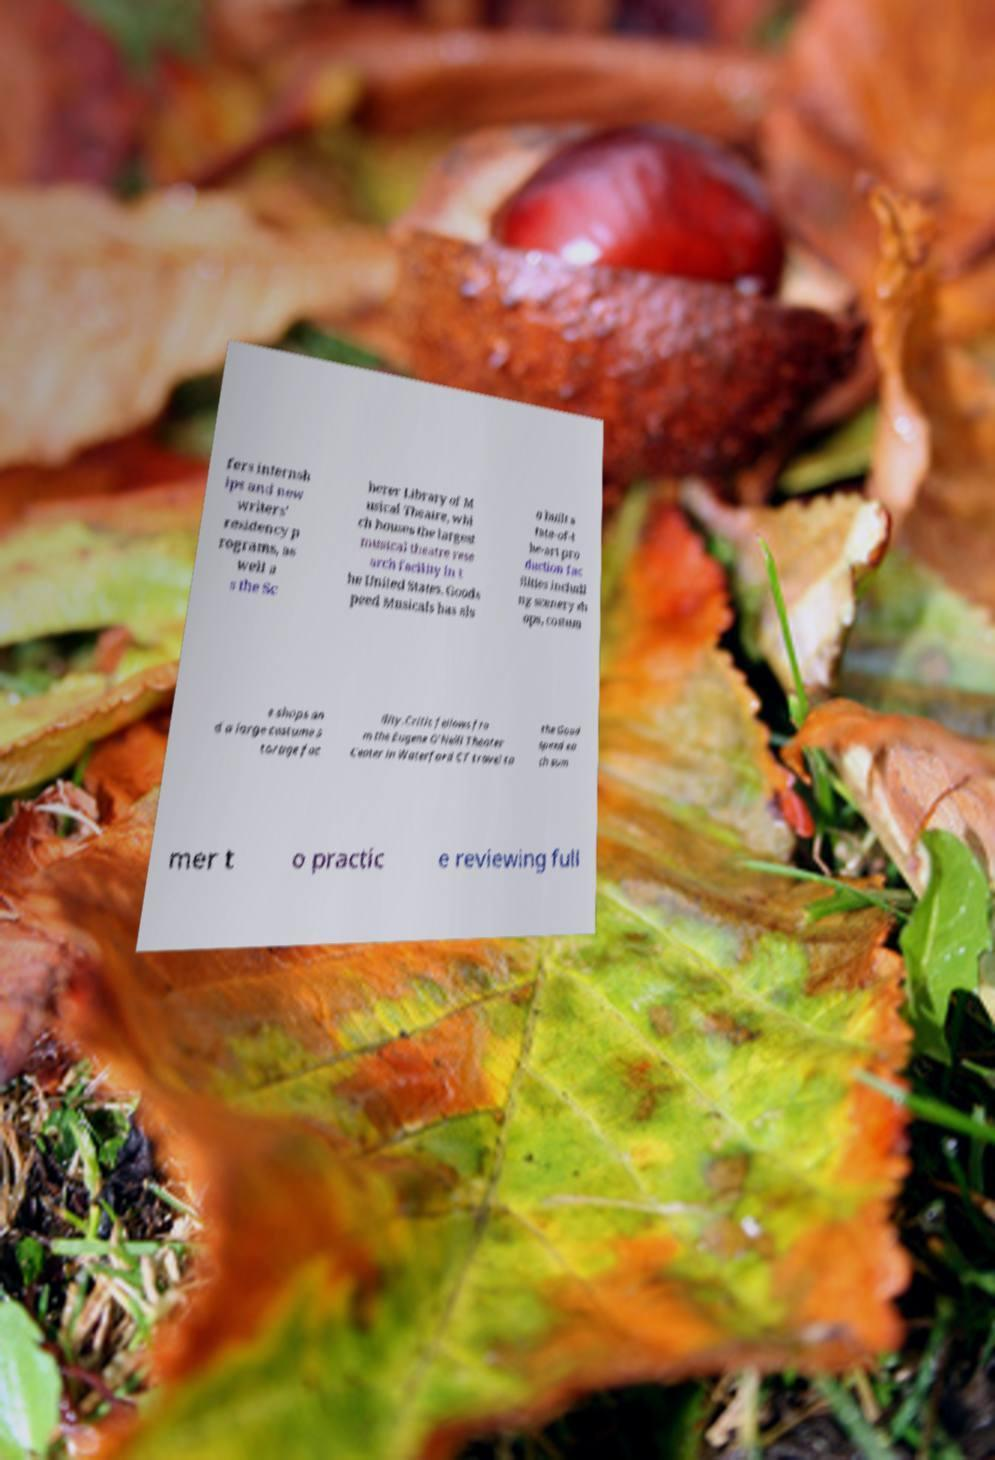For documentation purposes, I need the text within this image transcribed. Could you provide that? fers internsh ips and new writers' residency p rograms, as well a s the Sc herer Library of M usical Theatre, whi ch houses the largest musical theatre rese arch facility in t he United States. Goods peed Musicals has als o built s tate-of-t he-art pro duction fac ilities includi ng scenery sh ops, costum e shops an d a large costume s torage fac ility.Critic fellows fro m the Eugene O'Neill Theater Center in Waterford CT travel to the Good speed ea ch sum mer t o practic e reviewing full 